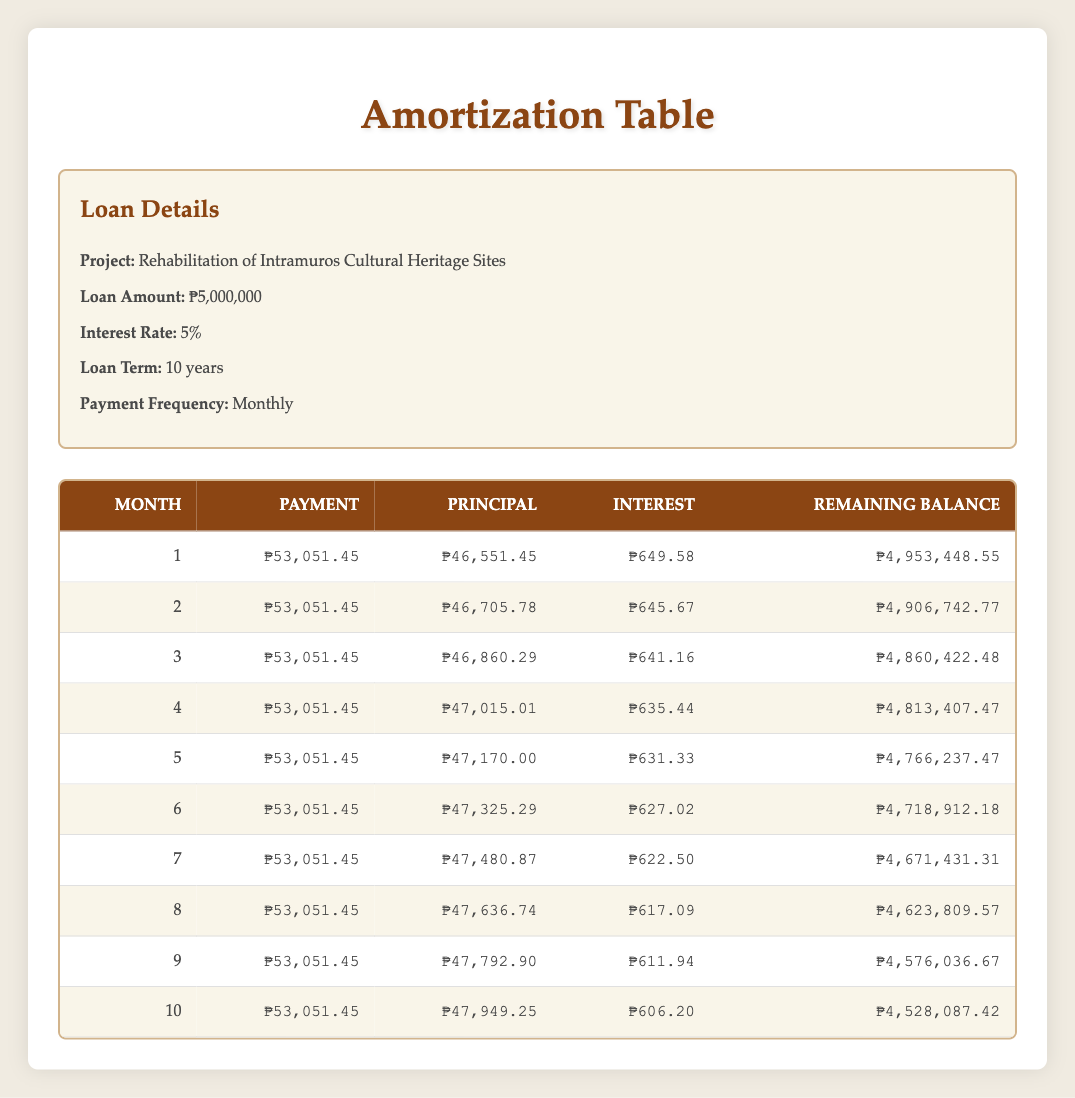What is the monthly payment amount for the loan? The table shows that the payment amount for each month is consistently ₱53,051.45, as indicated in each month's row under the "Payment" column.
Answer: ₱53,051.45 What is the principal amount paid in the third month? In the third month, the "Principal" column shows a value of ₱46,860.29.
Answer: ₱46,860.29 How much interest is paid in total for the first ten months? To calculate total interest paid, sum the interest amounts for each of the first ten months: 649.58 + 645.67 + 641.16 + 635.44 + 631.33 + 627.02 + 622.50 + 617.09 + 611.94 + 606.20 = 6,134.99.
Answer: ₱6,134.99 Is the remaining balance after the first month higher than the remaining balance after the tenth month? The remaining balance after the first month is ₱4,953,448.55, while the remaining balance after the tenth month is ₱4,528,087.42. Since ₱4,953,448.55 is greater than ₱4,528,087.42, the statement is true.
Answer: Yes What is the difference in principal payments between the first month and the fifth month? The principal payment in the first month is ₱46,551.45 and in the fifth month is ₱47,170.00. The difference is calculated as ₱47,170.00 - ₱46,551.45 = ₱618.55.
Answer: ₱618.55 What is the average monthly principal payment over the first ten months? To calculate the average, add all principal payments for the first ten months: 46,551.45 + 46,705.78 + 46,860.29 + 47,015.01 + 47,170.00 + 47,325.29 + 47,480.87 + 47,636.74 + 47,792.90 + 47,949.25 =  476,825.58. Then divide by 10 (the number of months), which gives us 476,825.58 / 10 = ₱47,682.56.
Answer: ₱47,682.56 In which month is the payment amount the same as in the first month? The table shows that the payment amount is constant at ₱53,051.45 for all ten months, including the first month.
Answer: All months Is the total payment made in the second month greater than the total of the interest payments for the first two months? The total payment in the second month is ₱53,051.45. The total interest for the first two months is ₱649.58 + ₱645.67 = ₱1,295.25. Since ₱53,051.45 is greater than ₱1,295.25, the statement is true.
Answer: Yes How much is the remaining balance after the sixth month compared to that after the sixth month? The remaining balance after the sixth month is ₱4,718,912.18, and it is compared to itself, which means they are equal.
Answer: Equal 